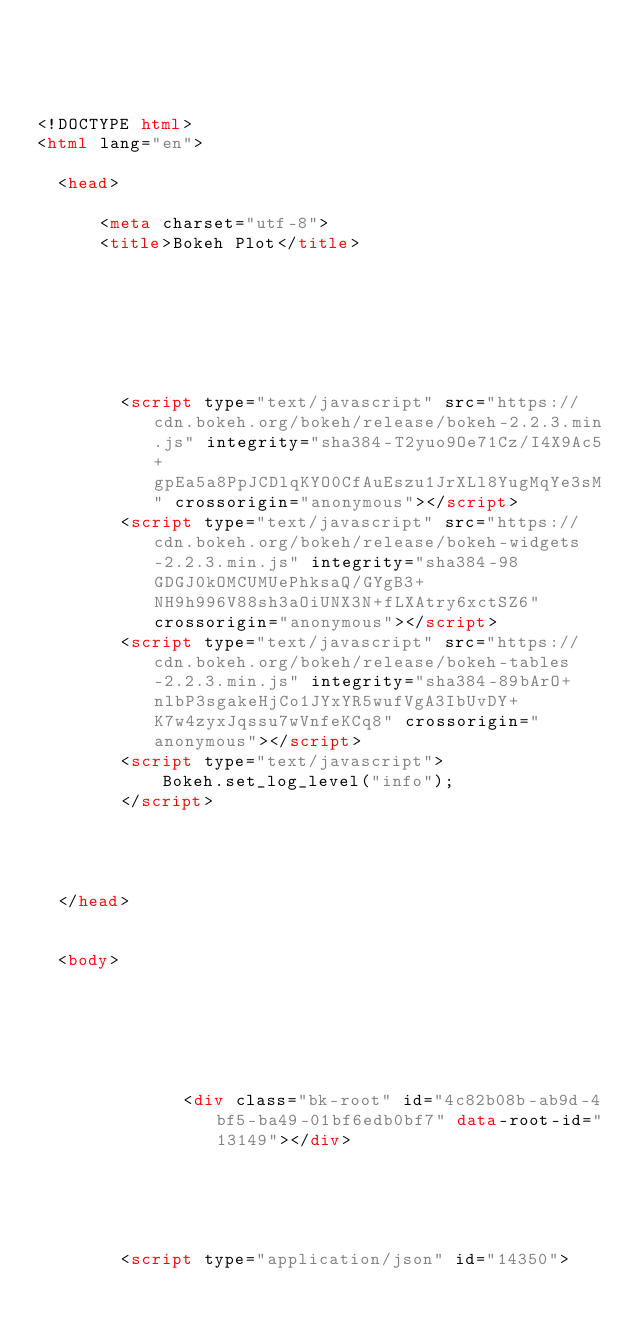Convert code to text. <code><loc_0><loc_0><loc_500><loc_500><_HTML_>



<!DOCTYPE html>
<html lang="en">
  
  <head>
    
      <meta charset="utf-8">
      <title>Bokeh Plot</title>
      
      
        
          
        
        
          
        <script type="text/javascript" src="https://cdn.bokeh.org/bokeh/release/bokeh-2.2.3.min.js" integrity="sha384-T2yuo9Oe71Cz/I4X9Ac5+gpEa5a8PpJCDlqKYO0CfAuEszu1JrXLl8YugMqYe3sM" crossorigin="anonymous"></script>
        <script type="text/javascript" src="https://cdn.bokeh.org/bokeh/release/bokeh-widgets-2.2.3.min.js" integrity="sha384-98GDGJ0kOMCUMUePhksaQ/GYgB3+NH9h996V88sh3aOiUNX3N+fLXAtry6xctSZ6" crossorigin="anonymous"></script>
        <script type="text/javascript" src="https://cdn.bokeh.org/bokeh/release/bokeh-tables-2.2.3.min.js" integrity="sha384-89bArO+nlbP3sgakeHjCo1JYxYR5wufVgA3IbUvDY+K7w4zyxJqssu7wVnfeKCq8" crossorigin="anonymous"></script>
        <script type="text/javascript">
            Bokeh.set_log_level("info");
        </script>
        
      
      
    
  </head>
  
  
  <body>
    
      
        
          
          
            
              <div class="bk-root" id="4c82b08b-ab9d-4bf5-ba49-01bf6edb0bf7" data-root-id="13149"></div>
            
          
        
      
      
        <script type="application/json" id="14350"></code> 